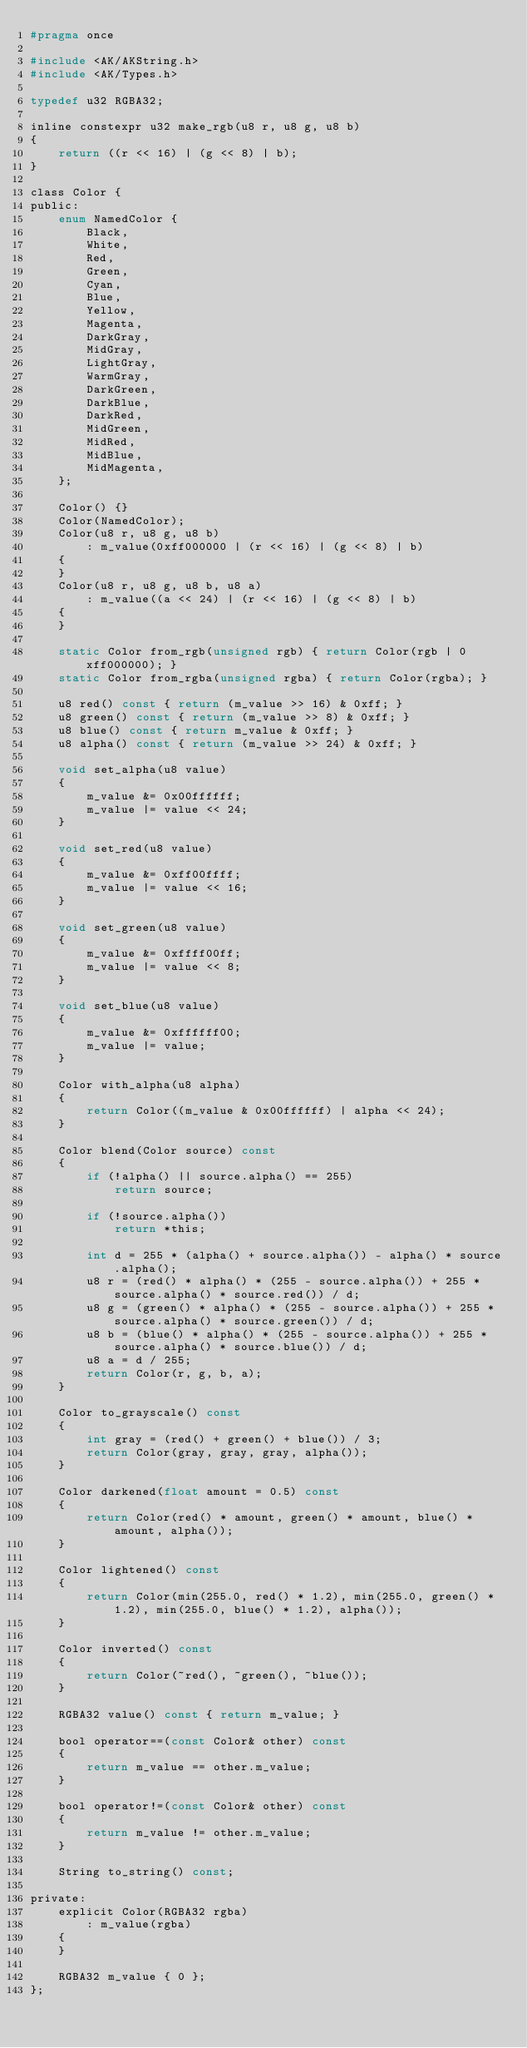Convert code to text. <code><loc_0><loc_0><loc_500><loc_500><_C_>#pragma once

#include <AK/AKString.h>
#include <AK/Types.h>

typedef u32 RGBA32;

inline constexpr u32 make_rgb(u8 r, u8 g, u8 b)
{
    return ((r << 16) | (g << 8) | b);
}

class Color {
public:
    enum NamedColor {
        Black,
        White,
        Red,
        Green,
        Cyan,
        Blue,
        Yellow,
        Magenta,
        DarkGray,
        MidGray,
        LightGray,
        WarmGray,
        DarkGreen,
        DarkBlue,
        DarkRed,
        MidGreen,
        MidRed,
        MidBlue,
        MidMagenta,
    };

    Color() {}
    Color(NamedColor);
    Color(u8 r, u8 g, u8 b)
        : m_value(0xff000000 | (r << 16) | (g << 8) | b)
    {
    }
    Color(u8 r, u8 g, u8 b, u8 a)
        : m_value((a << 24) | (r << 16) | (g << 8) | b)
    {
    }

    static Color from_rgb(unsigned rgb) { return Color(rgb | 0xff000000); }
    static Color from_rgba(unsigned rgba) { return Color(rgba); }

    u8 red() const { return (m_value >> 16) & 0xff; }
    u8 green() const { return (m_value >> 8) & 0xff; }
    u8 blue() const { return m_value & 0xff; }
    u8 alpha() const { return (m_value >> 24) & 0xff; }

    void set_alpha(u8 value)
    {
        m_value &= 0x00ffffff;
        m_value |= value << 24;
    }

    void set_red(u8 value)
    {
        m_value &= 0xff00ffff;
        m_value |= value << 16;
    }

    void set_green(u8 value)
    {
        m_value &= 0xffff00ff;
        m_value |= value << 8;
    }

    void set_blue(u8 value)
    {
        m_value &= 0xffffff00;
        m_value |= value;
    }

    Color with_alpha(u8 alpha)
    {
        return Color((m_value & 0x00ffffff) | alpha << 24);
    }

    Color blend(Color source) const
    {
        if (!alpha() || source.alpha() == 255)
            return source;

        if (!source.alpha())
            return *this;

        int d = 255 * (alpha() + source.alpha()) - alpha() * source.alpha();
        u8 r = (red() * alpha() * (255 - source.alpha()) + 255 * source.alpha() * source.red()) / d;
        u8 g = (green() * alpha() * (255 - source.alpha()) + 255 * source.alpha() * source.green()) / d;
        u8 b = (blue() * alpha() * (255 - source.alpha()) + 255 * source.alpha() * source.blue()) / d;
        u8 a = d / 255;
        return Color(r, g, b, a);
    }

    Color to_grayscale() const
    {
        int gray = (red() + green() + blue()) / 3;
        return Color(gray, gray, gray, alpha());
    }

    Color darkened(float amount = 0.5) const
    {
        return Color(red() * amount, green() * amount, blue() * amount, alpha());
    }

    Color lightened() const
    {
        return Color(min(255.0, red() * 1.2), min(255.0, green() * 1.2), min(255.0, blue() * 1.2), alpha());
    }

    Color inverted() const
    {
        return Color(~red(), ~green(), ~blue());
    }

    RGBA32 value() const { return m_value; }

    bool operator==(const Color& other) const
    {
        return m_value == other.m_value;
    }

    bool operator!=(const Color& other) const
    {
        return m_value != other.m_value;
    }

    String to_string() const;

private:
    explicit Color(RGBA32 rgba)
        : m_value(rgba)
    {
    }

    RGBA32 m_value { 0 };
};
</code> 